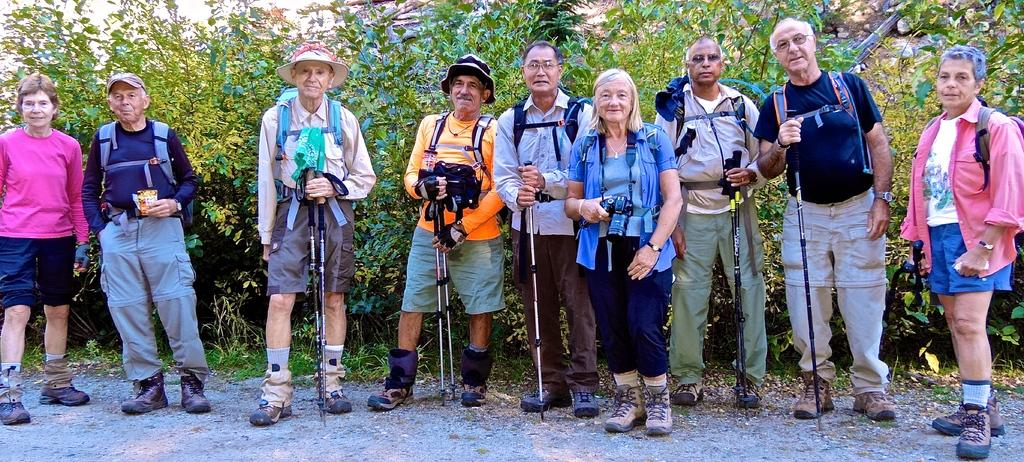What are the people in the image doing? The people in the image are standing on the ground. What are the people holding in their hands? The people are holding objects in the image. What can be seen in the background of the image? There are trees visible in the background of the image. How many babies are crawling on the ground in the image? There are no babies present in the image; it only shows people standing on the ground. What type of pail is being used by the people in the image? There is no pail visible in the image; the people are holding objects, but none of them resemble a pail. 